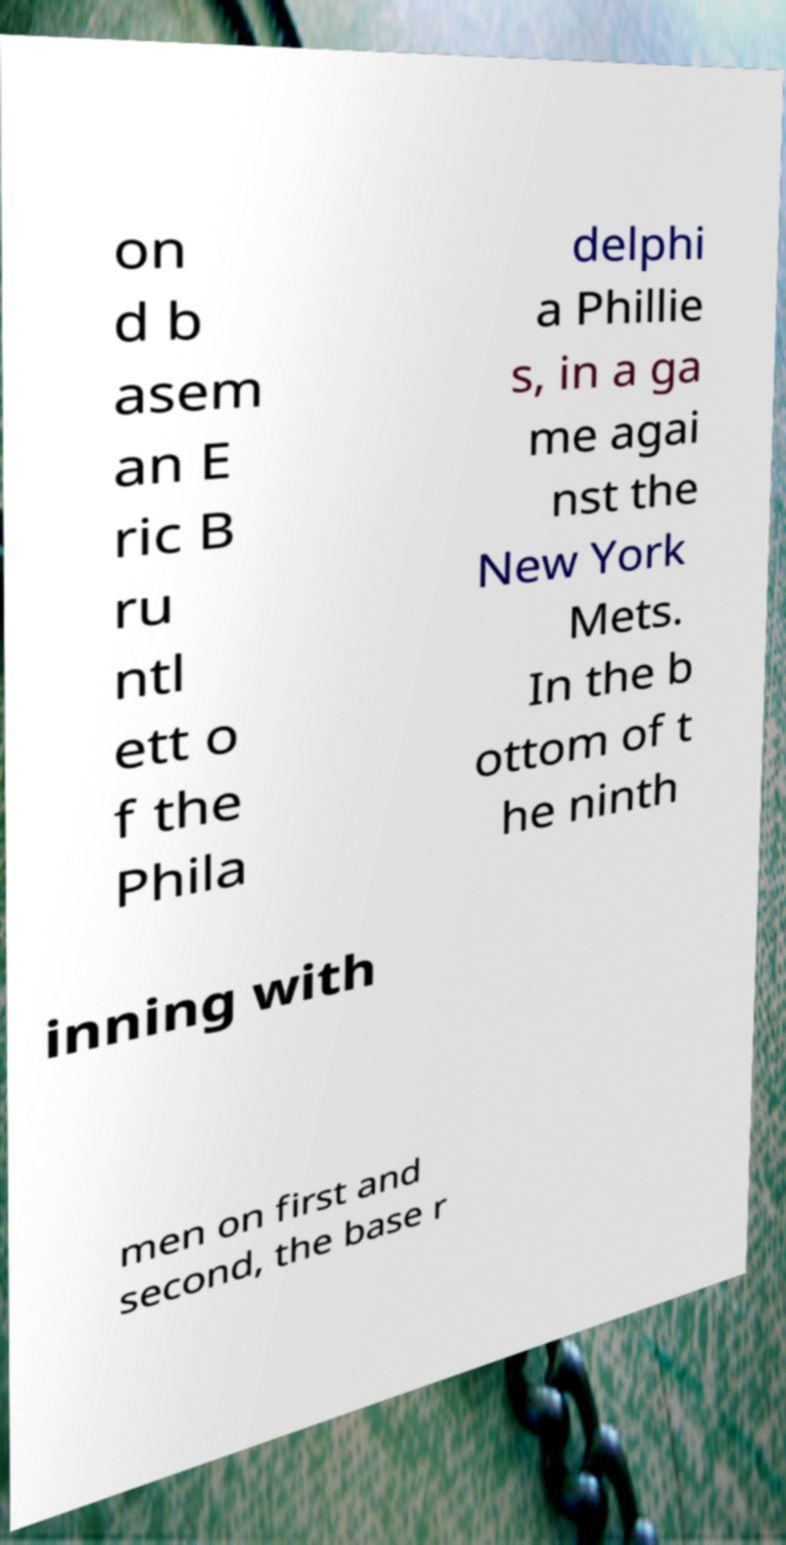Please identify and transcribe the text found in this image. on d b asem an E ric B ru ntl ett o f the Phila delphi a Phillie s, in a ga me agai nst the New York Mets. In the b ottom of t he ninth inning with men on first and second, the base r 